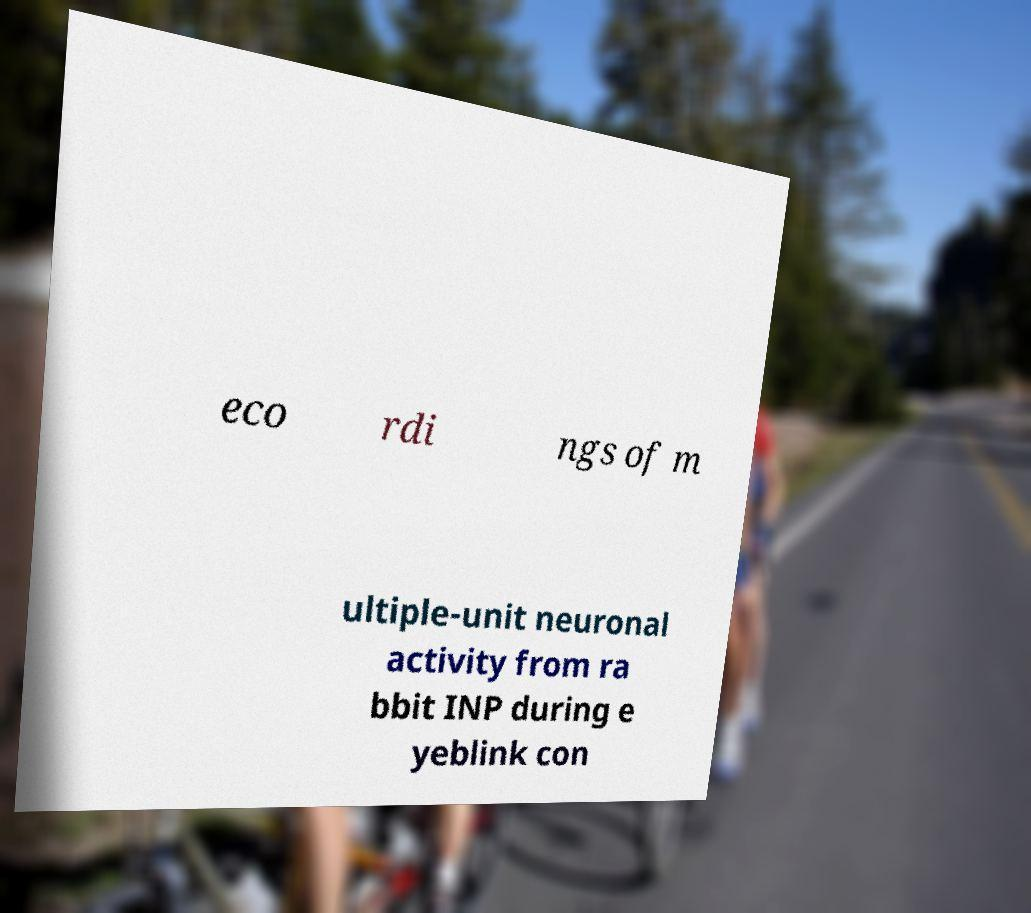There's text embedded in this image that I need extracted. Can you transcribe it verbatim? eco rdi ngs of m ultiple-unit neuronal activity from ra bbit INP during e yeblink con 